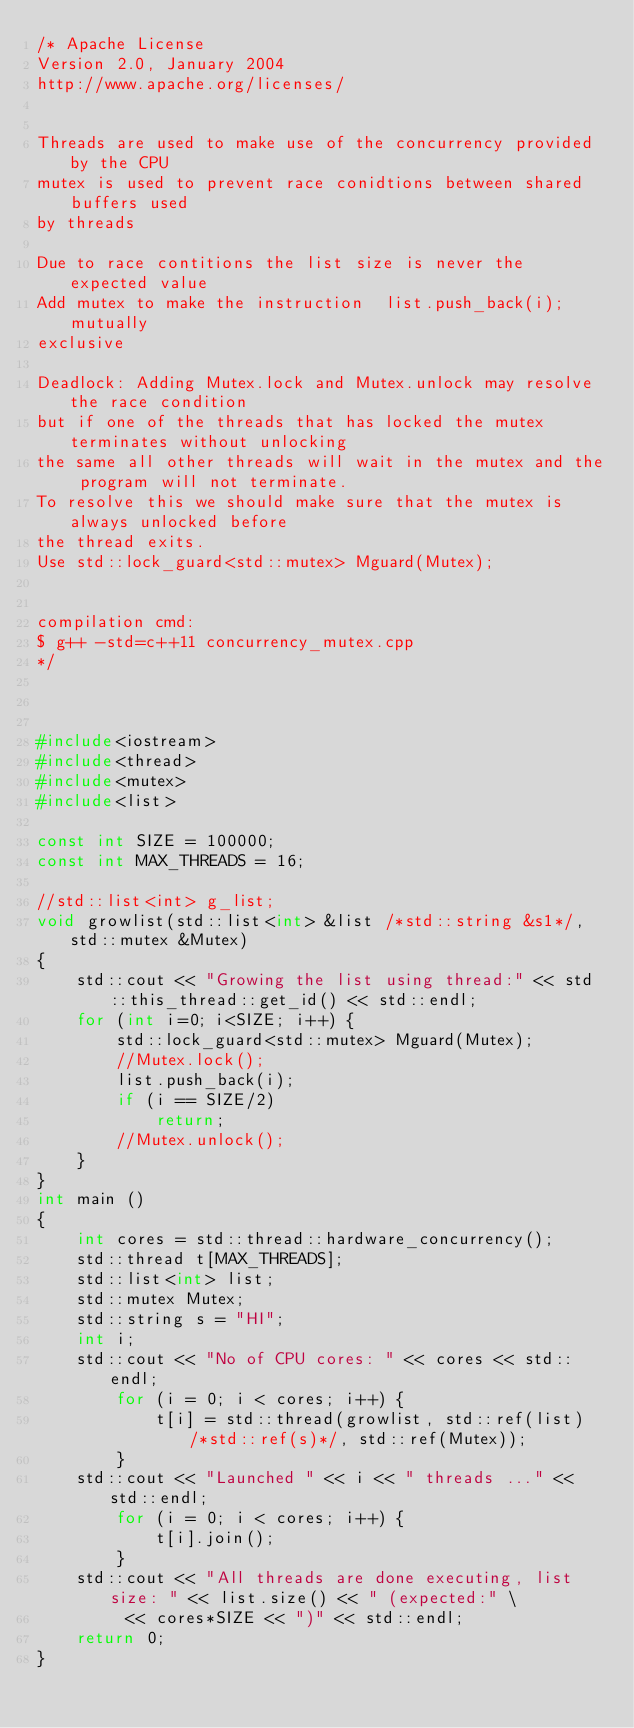<code> <loc_0><loc_0><loc_500><loc_500><_C++_>/* Apache License
Version 2.0, January 2004
http://www.apache.org/licenses/


Threads are used to make use of the concurrency provided by the CPU
mutex is used to prevent race conidtions between shared buffers used
by threads

Due to race contitions the list size is never the expected value
Add mutex to make the instruction  list.push_back(i); mutually
exclusive

Deadlock: Adding Mutex.lock and Mutex.unlock may resolve the race condition
but if one of the threads that has locked the mutex terminates without unlocking
the same all other threads will wait in the mutex and the program will not terminate.
To resolve this we should make sure that the mutex is always unlocked before
the thread exits.
Use std::lock_guard<std::mutex> Mguard(Mutex);


compilation cmd:
$ g++ -std=c++11 concurrency_mutex.cpp
*/



#include<iostream>
#include<thread>
#include<mutex>
#include<list>

const int SIZE = 100000;
const int MAX_THREADS = 16;

//std::list<int> g_list;
void growlist(std::list<int> &list /*std::string &s1*/, std::mutex &Mutex) 
{
	std::cout << "Growing the list using thread:" << std::this_thread::get_id() << std::endl;
	for (int i=0; i<SIZE; i++) {
		std::lock_guard<std::mutex> Mguard(Mutex);
		//Mutex.lock();
		list.push_back(i);
		if (i == SIZE/2)
			return;
		//Mutex.unlock();
	}
}
int main () 
{
	int cores = std::thread::hardware_concurrency();
	std::thread t[MAX_THREADS];
	std::list<int> list;
	std::mutex Mutex;
	std::string s = "HI";
	int i;
	std::cout << "No of CPU cores: " << cores << std::endl;
		for (i = 0; i < cores; i++) {
			t[i] = std::thread(growlist, std::ref(list) /*std::ref(s)*/, std::ref(Mutex));
		}
	std::cout << "Launched " << i << " threads ..." << std::endl;
		for (i = 0; i < cores; i++) {
			t[i].join();
		}
	std::cout << "All threads are done executing, list size: " << list.size() << " (expected:" \
		 << cores*SIZE << ")" << std::endl;
	return 0;
}
</code> 